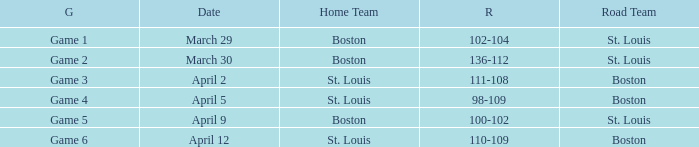On what Date is Game 3 with Boston Road Team? April 2. Can you give me this table as a dict? {'header': ['G', 'Date', 'Home Team', 'R', 'Road Team'], 'rows': [['Game 1', 'March 29', 'Boston', '102-104', 'St. Louis'], ['Game 2', 'March 30', 'Boston', '136-112', 'St. Louis'], ['Game 3', 'April 2', 'St. Louis', '111-108', 'Boston'], ['Game 4', 'April 5', 'St. Louis', '98-109', 'Boston'], ['Game 5', 'April 9', 'Boston', '100-102', 'St. Louis'], ['Game 6', 'April 12', 'St. Louis', '110-109', 'Boston']]} 